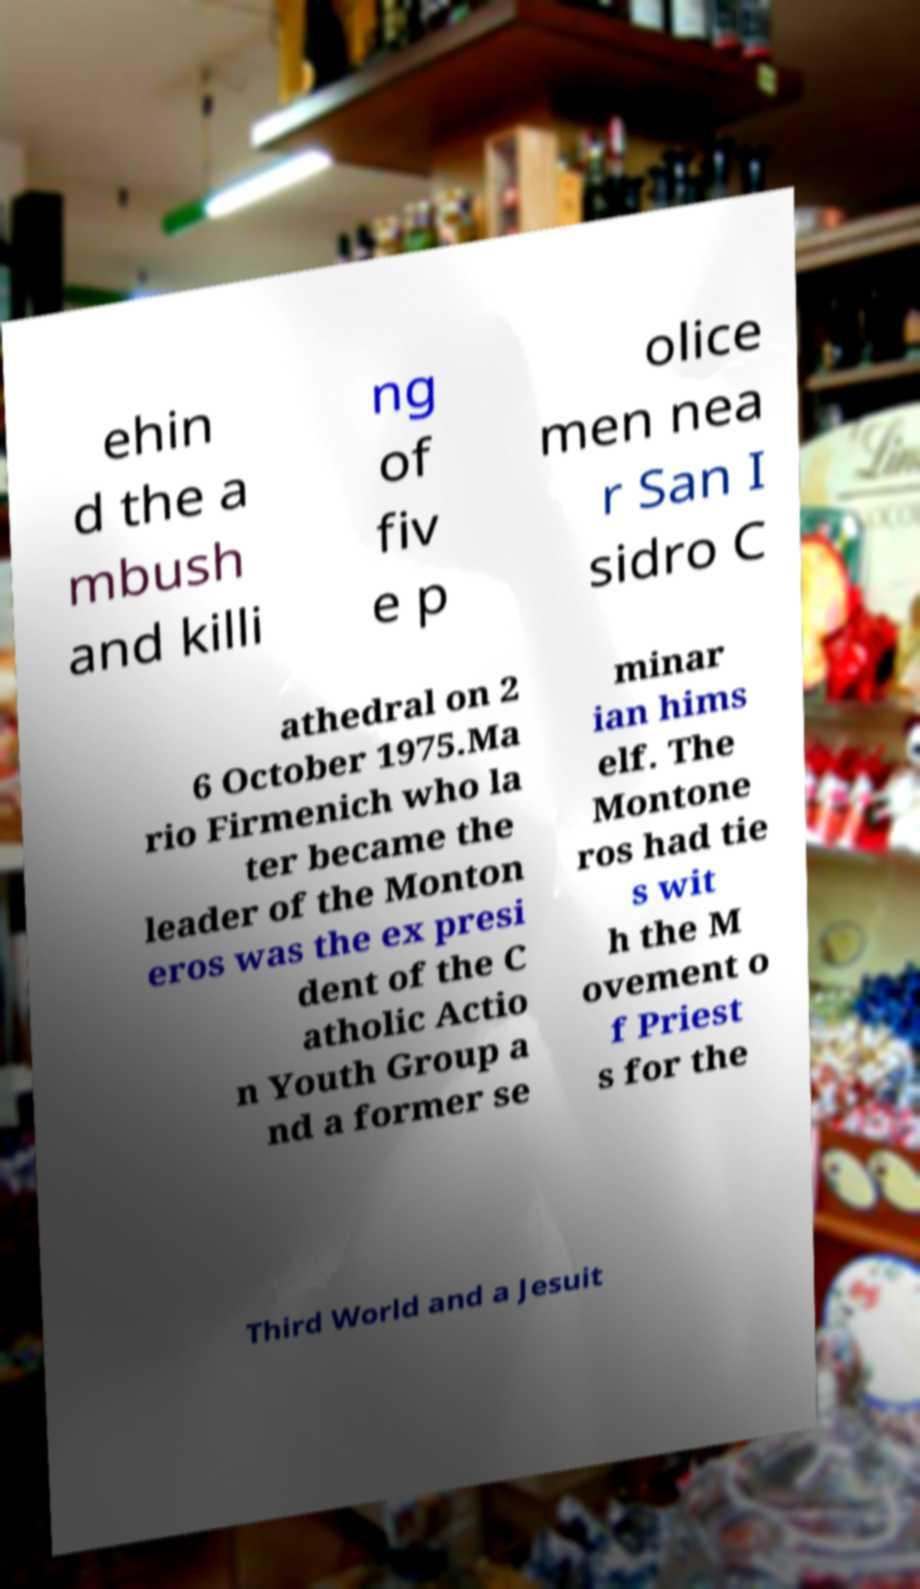Please identify and transcribe the text found in this image. ehin d the a mbush and killi ng of fiv e p olice men nea r San I sidro C athedral on 2 6 October 1975.Ma rio Firmenich who la ter became the leader of the Monton eros was the ex presi dent of the C atholic Actio n Youth Group a nd a former se minar ian hims elf. The Montone ros had tie s wit h the M ovement o f Priest s for the Third World and a Jesuit 